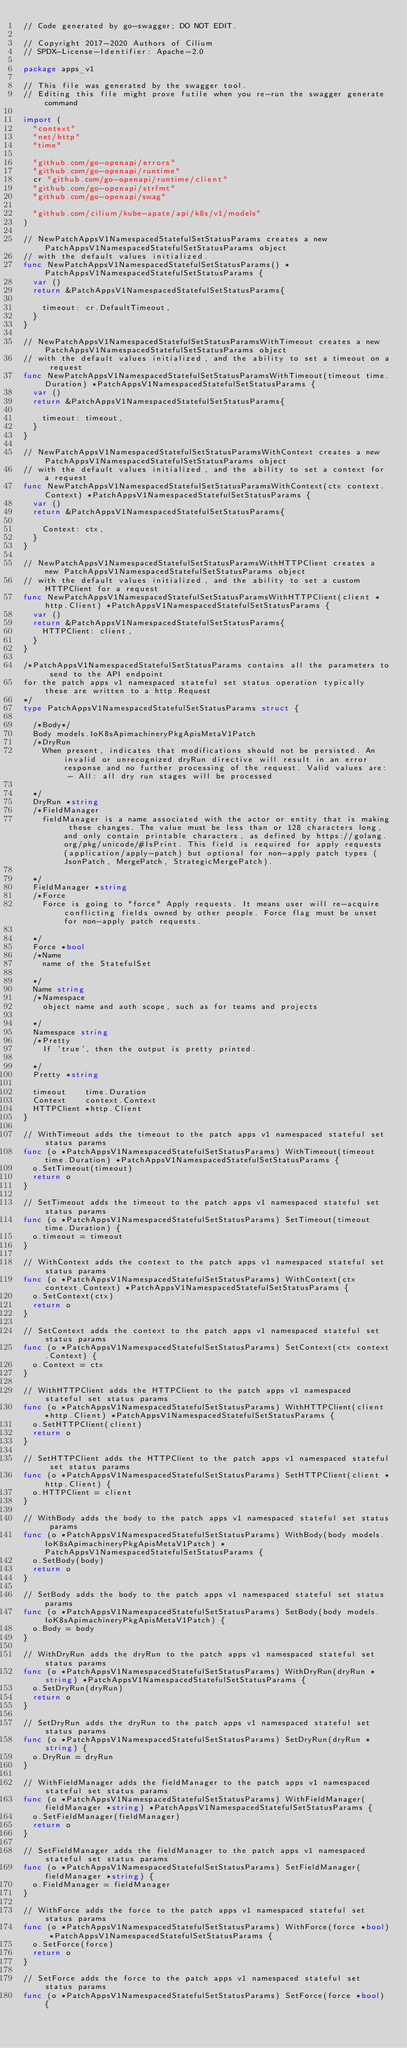Convert code to text. <code><loc_0><loc_0><loc_500><loc_500><_Go_>// Code generated by go-swagger; DO NOT EDIT.

// Copyright 2017-2020 Authors of Cilium
// SPDX-License-Identifier: Apache-2.0

package apps_v1

// This file was generated by the swagger tool.
// Editing this file might prove futile when you re-run the swagger generate command

import (
	"context"
	"net/http"
	"time"

	"github.com/go-openapi/errors"
	"github.com/go-openapi/runtime"
	cr "github.com/go-openapi/runtime/client"
	"github.com/go-openapi/strfmt"
	"github.com/go-openapi/swag"

	"github.com/cilium/kube-apate/api/k8s/v1/models"
)

// NewPatchAppsV1NamespacedStatefulSetStatusParams creates a new PatchAppsV1NamespacedStatefulSetStatusParams object
// with the default values initialized.
func NewPatchAppsV1NamespacedStatefulSetStatusParams() *PatchAppsV1NamespacedStatefulSetStatusParams {
	var ()
	return &PatchAppsV1NamespacedStatefulSetStatusParams{

		timeout: cr.DefaultTimeout,
	}
}

// NewPatchAppsV1NamespacedStatefulSetStatusParamsWithTimeout creates a new PatchAppsV1NamespacedStatefulSetStatusParams object
// with the default values initialized, and the ability to set a timeout on a request
func NewPatchAppsV1NamespacedStatefulSetStatusParamsWithTimeout(timeout time.Duration) *PatchAppsV1NamespacedStatefulSetStatusParams {
	var ()
	return &PatchAppsV1NamespacedStatefulSetStatusParams{

		timeout: timeout,
	}
}

// NewPatchAppsV1NamespacedStatefulSetStatusParamsWithContext creates a new PatchAppsV1NamespacedStatefulSetStatusParams object
// with the default values initialized, and the ability to set a context for a request
func NewPatchAppsV1NamespacedStatefulSetStatusParamsWithContext(ctx context.Context) *PatchAppsV1NamespacedStatefulSetStatusParams {
	var ()
	return &PatchAppsV1NamespacedStatefulSetStatusParams{

		Context: ctx,
	}
}

// NewPatchAppsV1NamespacedStatefulSetStatusParamsWithHTTPClient creates a new PatchAppsV1NamespacedStatefulSetStatusParams object
// with the default values initialized, and the ability to set a custom HTTPClient for a request
func NewPatchAppsV1NamespacedStatefulSetStatusParamsWithHTTPClient(client *http.Client) *PatchAppsV1NamespacedStatefulSetStatusParams {
	var ()
	return &PatchAppsV1NamespacedStatefulSetStatusParams{
		HTTPClient: client,
	}
}

/*PatchAppsV1NamespacedStatefulSetStatusParams contains all the parameters to send to the API endpoint
for the patch apps v1 namespaced stateful set status operation typically these are written to a http.Request
*/
type PatchAppsV1NamespacedStatefulSetStatusParams struct {

	/*Body*/
	Body models.IoK8sApimachineryPkgApisMetaV1Patch
	/*DryRun
	  When present, indicates that modifications should not be persisted. An invalid or unrecognized dryRun directive will result in an error response and no further processing of the request. Valid values are: - All: all dry run stages will be processed

	*/
	DryRun *string
	/*FieldManager
	  fieldManager is a name associated with the actor or entity that is making these changes. The value must be less than or 128 characters long, and only contain printable characters, as defined by https://golang.org/pkg/unicode/#IsPrint. This field is required for apply requests (application/apply-patch) but optional for non-apply patch types (JsonPatch, MergePatch, StrategicMergePatch).

	*/
	FieldManager *string
	/*Force
	  Force is going to "force" Apply requests. It means user will re-acquire conflicting fields owned by other people. Force flag must be unset for non-apply patch requests.

	*/
	Force *bool
	/*Name
	  name of the StatefulSet

	*/
	Name string
	/*Namespace
	  object name and auth scope, such as for teams and projects

	*/
	Namespace string
	/*Pretty
	  If 'true', then the output is pretty printed.

	*/
	Pretty *string

	timeout    time.Duration
	Context    context.Context
	HTTPClient *http.Client
}

// WithTimeout adds the timeout to the patch apps v1 namespaced stateful set status params
func (o *PatchAppsV1NamespacedStatefulSetStatusParams) WithTimeout(timeout time.Duration) *PatchAppsV1NamespacedStatefulSetStatusParams {
	o.SetTimeout(timeout)
	return o
}

// SetTimeout adds the timeout to the patch apps v1 namespaced stateful set status params
func (o *PatchAppsV1NamespacedStatefulSetStatusParams) SetTimeout(timeout time.Duration) {
	o.timeout = timeout
}

// WithContext adds the context to the patch apps v1 namespaced stateful set status params
func (o *PatchAppsV1NamespacedStatefulSetStatusParams) WithContext(ctx context.Context) *PatchAppsV1NamespacedStatefulSetStatusParams {
	o.SetContext(ctx)
	return o
}

// SetContext adds the context to the patch apps v1 namespaced stateful set status params
func (o *PatchAppsV1NamespacedStatefulSetStatusParams) SetContext(ctx context.Context) {
	o.Context = ctx
}

// WithHTTPClient adds the HTTPClient to the patch apps v1 namespaced stateful set status params
func (o *PatchAppsV1NamespacedStatefulSetStatusParams) WithHTTPClient(client *http.Client) *PatchAppsV1NamespacedStatefulSetStatusParams {
	o.SetHTTPClient(client)
	return o
}

// SetHTTPClient adds the HTTPClient to the patch apps v1 namespaced stateful set status params
func (o *PatchAppsV1NamespacedStatefulSetStatusParams) SetHTTPClient(client *http.Client) {
	o.HTTPClient = client
}

// WithBody adds the body to the patch apps v1 namespaced stateful set status params
func (o *PatchAppsV1NamespacedStatefulSetStatusParams) WithBody(body models.IoK8sApimachineryPkgApisMetaV1Patch) *PatchAppsV1NamespacedStatefulSetStatusParams {
	o.SetBody(body)
	return o
}

// SetBody adds the body to the patch apps v1 namespaced stateful set status params
func (o *PatchAppsV1NamespacedStatefulSetStatusParams) SetBody(body models.IoK8sApimachineryPkgApisMetaV1Patch) {
	o.Body = body
}

// WithDryRun adds the dryRun to the patch apps v1 namespaced stateful set status params
func (o *PatchAppsV1NamespacedStatefulSetStatusParams) WithDryRun(dryRun *string) *PatchAppsV1NamespacedStatefulSetStatusParams {
	o.SetDryRun(dryRun)
	return o
}

// SetDryRun adds the dryRun to the patch apps v1 namespaced stateful set status params
func (o *PatchAppsV1NamespacedStatefulSetStatusParams) SetDryRun(dryRun *string) {
	o.DryRun = dryRun
}

// WithFieldManager adds the fieldManager to the patch apps v1 namespaced stateful set status params
func (o *PatchAppsV1NamespacedStatefulSetStatusParams) WithFieldManager(fieldManager *string) *PatchAppsV1NamespacedStatefulSetStatusParams {
	o.SetFieldManager(fieldManager)
	return o
}

// SetFieldManager adds the fieldManager to the patch apps v1 namespaced stateful set status params
func (o *PatchAppsV1NamespacedStatefulSetStatusParams) SetFieldManager(fieldManager *string) {
	o.FieldManager = fieldManager
}

// WithForce adds the force to the patch apps v1 namespaced stateful set status params
func (o *PatchAppsV1NamespacedStatefulSetStatusParams) WithForce(force *bool) *PatchAppsV1NamespacedStatefulSetStatusParams {
	o.SetForce(force)
	return o
}

// SetForce adds the force to the patch apps v1 namespaced stateful set status params
func (o *PatchAppsV1NamespacedStatefulSetStatusParams) SetForce(force *bool) {</code> 